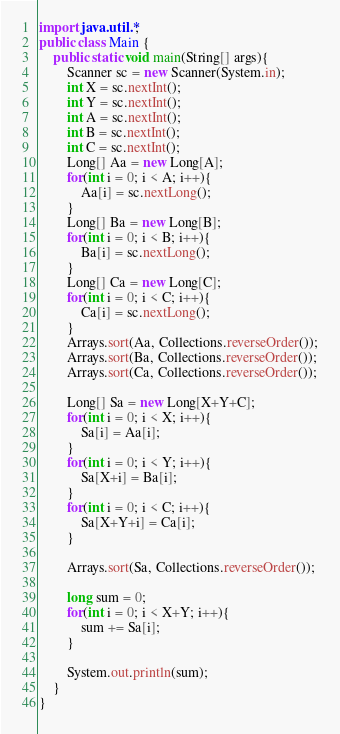Convert code to text. <code><loc_0><loc_0><loc_500><loc_500><_Java_>import java.util.*;
public class Main {
	public static void main(String[] args){
		Scanner sc = new Scanner(System.in);
		int X = sc.nextInt();
      	int Y = sc.nextInt();
      	int A = sc.nextInt();
      	int B = sc.nextInt();
     	int C = sc.nextInt();
        Long[] Aa = new Long[A];
      	for(int i = 0; i < A; i++){
        	Aa[i] = sc.nextLong();
        }
      	Long[] Ba = new Long[B];
      	for(int i = 0; i < B; i++){
        	Ba[i] = sc.nextLong();
        }
      	Long[] Ca = new Long[C];
      	for(int i = 0; i < C; i++){
        	Ca[i] = sc.nextLong();
        }
      	Arrays.sort(Aa, Collections.reverseOrder());
      	Arrays.sort(Ba, Collections.reverseOrder());
      	Arrays.sort(Ca, Collections.reverseOrder());
      
      	Long[] Sa = new Long[X+Y+C];
      	for(int i = 0; i < X; i++){
        	Sa[i] = Aa[i];
        }
      	for(int i = 0; i < Y; i++){
        	Sa[X+i] = Ba[i];
        }
      	for(int i = 0; i < C; i++){
        	Sa[X+Y+i] = Ca[i];
        }
      
      	Arrays.sort(Sa, Collections.reverseOrder());
      
		long sum = 0;
      	for(int i = 0; i < X+Y; i++){
        	sum += Sa[i];
        }

		System.out.println(sum);
	}
}</code> 